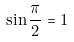Convert formula to latex. <formula><loc_0><loc_0><loc_500><loc_500>\sin \frac { \pi } { 2 } = 1</formula> 